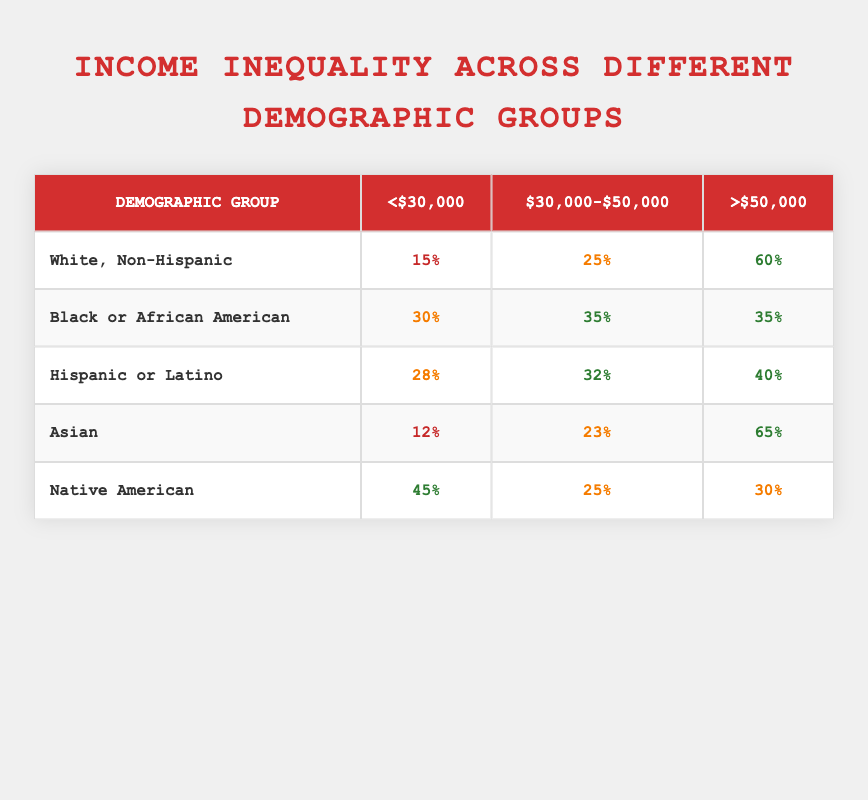What is the percentage of White, Non-Hispanic individuals earning less than $30,000? The table shows that 15% of the White, Non-Hispanic demographic group earns less than $30,000.
Answer: 15% Which demographic group has the highest percentage of individuals earning above $50,000? According to the table, the Asian demographic group has 65% of its individuals earning above $50,000, which is the highest percentage among all groups.
Answer: Asian What is the difference in percentage between Black or African American individuals earning $30,000-$50,000 and those earning >$50,000? The percentage of Black or African American individuals earning $30,000-$50,000 is 35%, while the percentage earning over $50,000 is also 35%. The difference is 35% - 35% = 0%.
Answer: 0% Is it true that Hispanic or Latino individuals have a lower percentage earning <$30,000 compared to Native Americans? The table shows that 28% of Hispanic or Latino individuals earn less than $30,000, while 45% of Native Americans earn less than that amount. Therefore, it is true that Hispanic or Latino individuals have a lower percentage.
Answer: Yes What is the average percentage of individuals for each income bracket across all demographic groups? To find the average for each income bracket, sum the percentages for each bracket and then divide by the number of groups. For <$30,000: (15 + 30 + 28 + 12 + 45) / 5 = 26%. For $30,000-$50,000: (25 + 35 + 32 + 23 + 25) / 5 = 28%. For >$50,000: (60 + 35 + 40 + 65 + 30) / 5 = 44%. So, the averages are 26%, 28%, and 44%.
Answer: 26%, 28%, 44% 